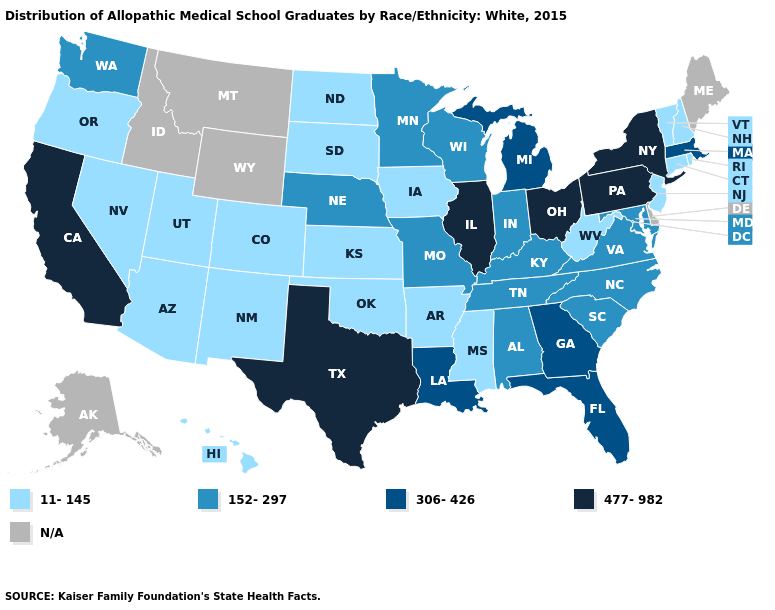Does the map have missing data?
Give a very brief answer. Yes. Name the states that have a value in the range 11-145?
Be succinct. Arizona, Arkansas, Colorado, Connecticut, Hawaii, Iowa, Kansas, Mississippi, Nevada, New Hampshire, New Jersey, New Mexico, North Dakota, Oklahoma, Oregon, Rhode Island, South Dakota, Utah, Vermont, West Virginia. What is the value of Illinois?
Short answer required. 477-982. Does Mississippi have the lowest value in the South?
Concise answer only. Yes. Name the states that have a value in the range 152-297?
Give a very brief answer. Alabama, Indiana, Kentucky, Maryland, Minnesota, Missouri, Nebraska, North Carolina, South Carolina, Tennessee, Virginia, Washington, Wisconsin. What is the value of Wyoming?
Short answer required. N/A. What is the lowest value in states that border New Jersey?
Answer briefly. 477-982. Name the states that have a value in the range 11-145?
Keep it brief. Arizona, Arkansas, Colorado, Connecticut, Hawaii, Iowa, Kansas, Mississippi, Nevada, New Hampshire, New Jersey, New Mexico, North Dakota, Oklahoma, Oregon, Rhode Island, South Dakota, Utah, Vermont, West Virginia. Name the states that have a value in the range N/A?
Give a very brief answer. Alaska, Delaware, Idaho, Maine, Montana, Wyoming. What is the value of Nevada?
Give a very brief answer. 11-145. Name the states that have a value in the range 152-297?
Give a very brief answer. Alabama, Indiana, Kentucky, Maryland, Minnesota, Missouri, Nebraska, North Carolina, South Carolina, Tennessee, Virginia, Washington, Wisconsin. Name the states that have a value in the range 477-982?
Write a very short answer. California, Illinois, New York, Ohio, Pennsylvania, Texas. What is the lowest value in the USA?
Short answer required. 11-145. 